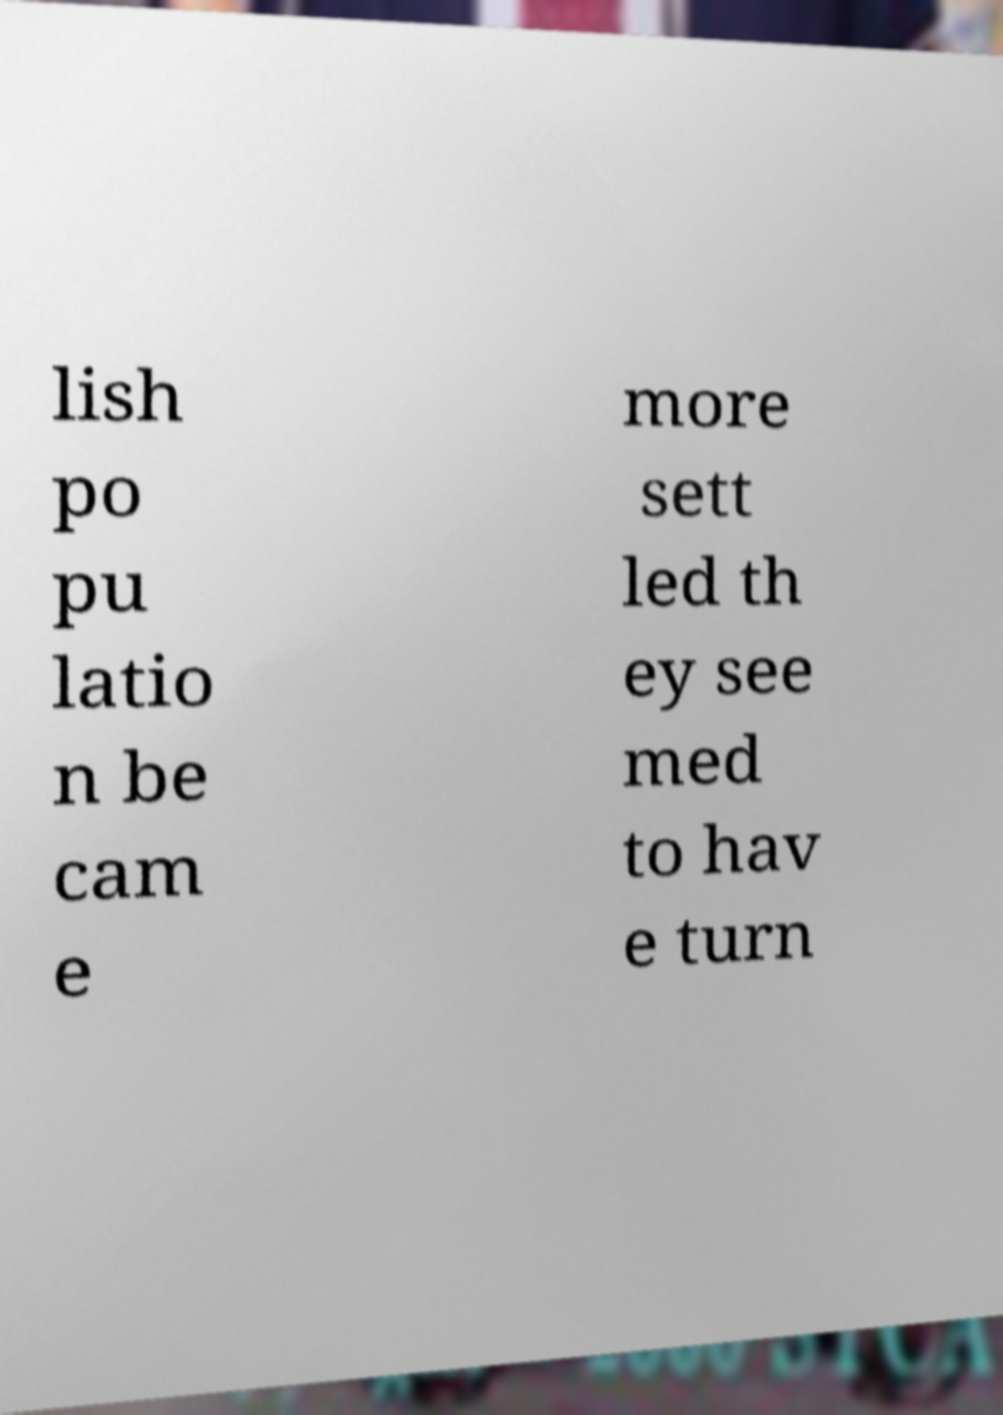Can you accurately transcribe the text from the provided image for me? lish po pu latio n be cam e more sett led th ey see med to hav e turn 